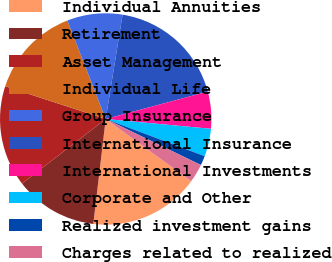Convert chart. <chart><loc_0><loc_0><loc_500><loc_500><pie_chart><fcel>Individual Annuities<fcel>Retirement<fcel>Asset Management<fcel>Individual Life<fcel>Group Insurance<fcel>International Insurance<fcel>International Investments<fcel>Corporate and Other<fcel>Realized investment gains<fcel>Charges related to realized<nl><fcel>16.87%<fcel>12.67%<fcel>15.47%<fcel>14.07%<fcel>8.46%<fcel>18.28%<fcel>5.65%<fcel>4.25%<fcel>1.44%<fcel>2.84%<nl></chart> 